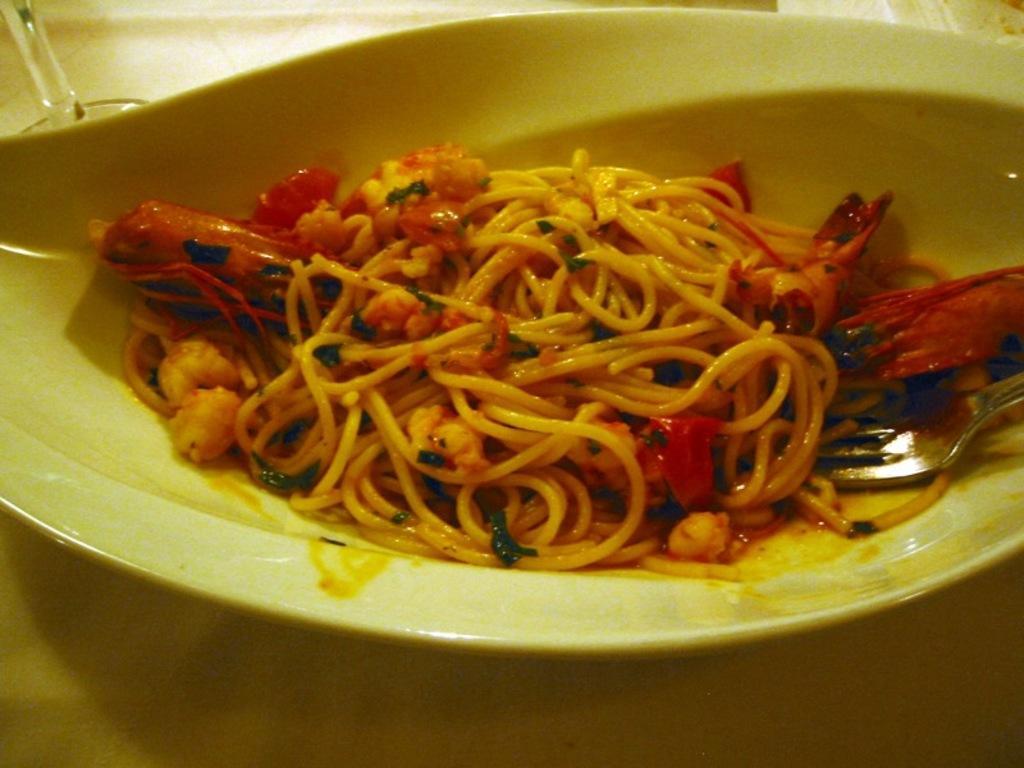Describe this image in one or two sentences. Here we can see a plate, fork, and food on the platform. 